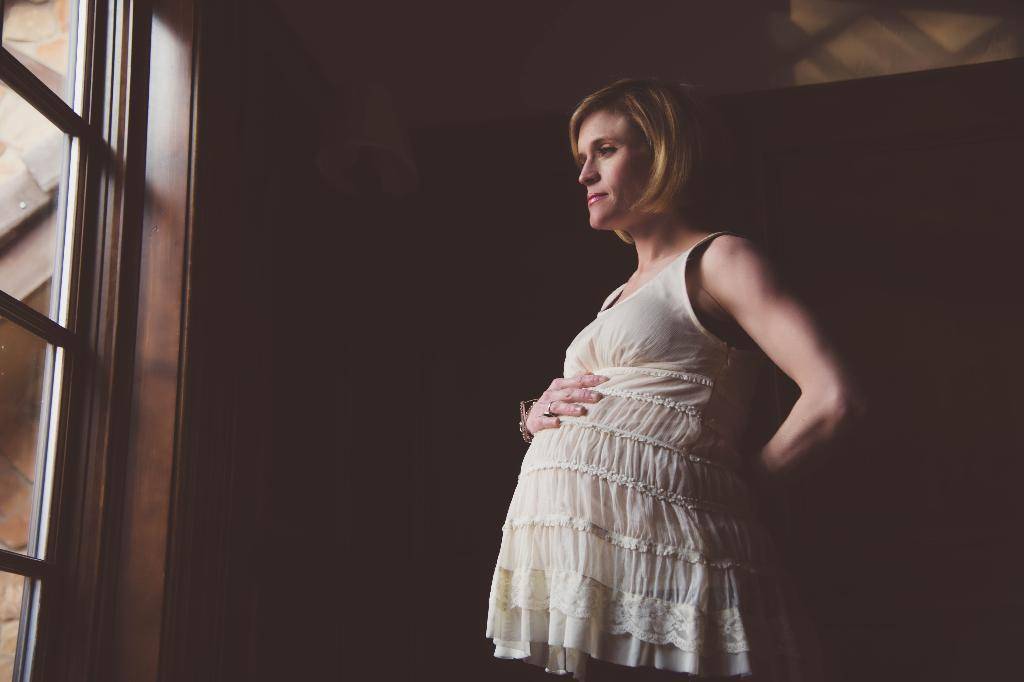What is the main subject of the image? The main subject of the image is a pregnant woman. What is the pregnant woman wearing? The pregnant woman is wearing a cream-colored dress. How is the pregnant woman interacting with her body in the image? The pregnant woman has one hand placed on her stomach. What can be seen behind the pregnant woman? There is a glass door in front of the pregnant woman. What type of fork is the pregnant woman holding in the image? There is no fork present in the image. How does the pregnant woman use her thumb to interact with the butter in the image? There is no butter or thumb interaction present in the image. 